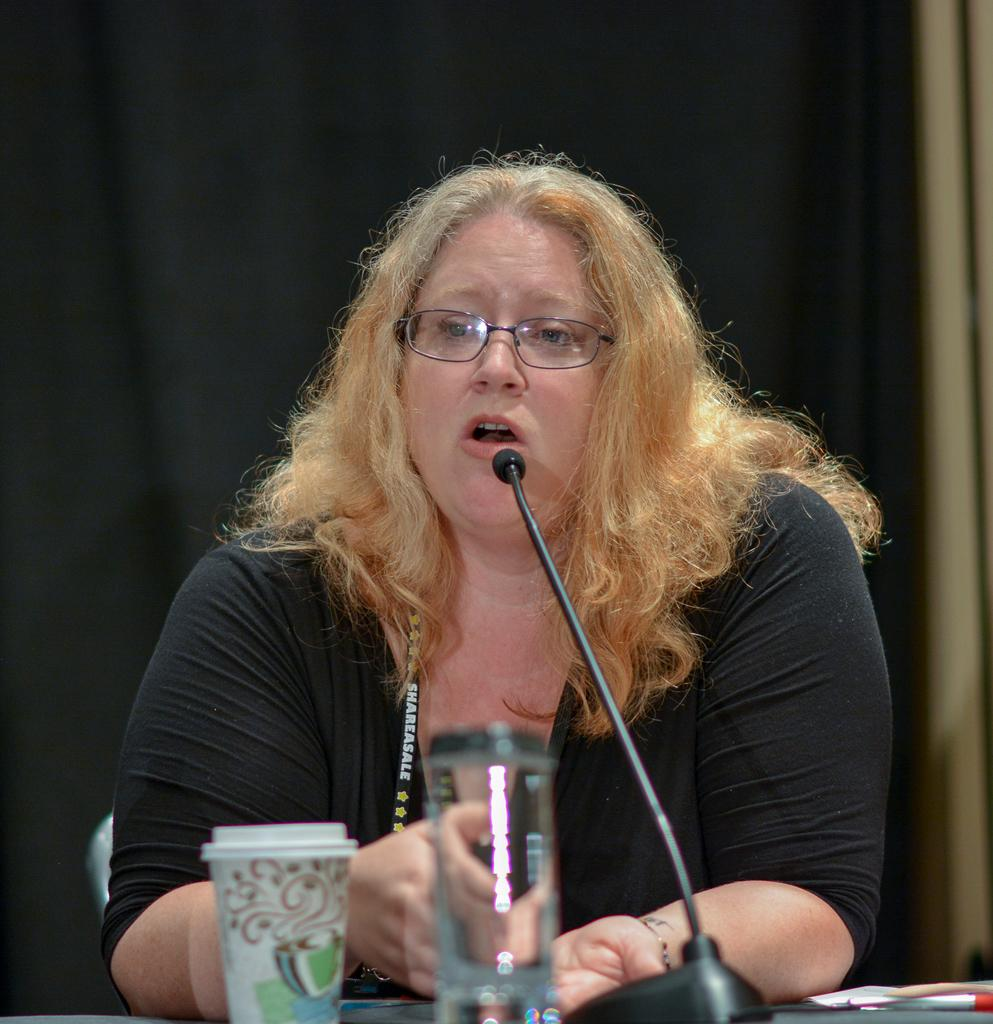What is the woman doing in the image? The woman is sitting at the table in the image. What objects are on the table with the woman? There is a mic, a glass tumbler, a glass, and a pen on the table. What can be seen in the background of the image? There is a wall and a curtain in the background of the image. What type of bear is sitting next to the woman in the image? There is no bear present in the image; it only features a woman sitting at a table with various objects. 